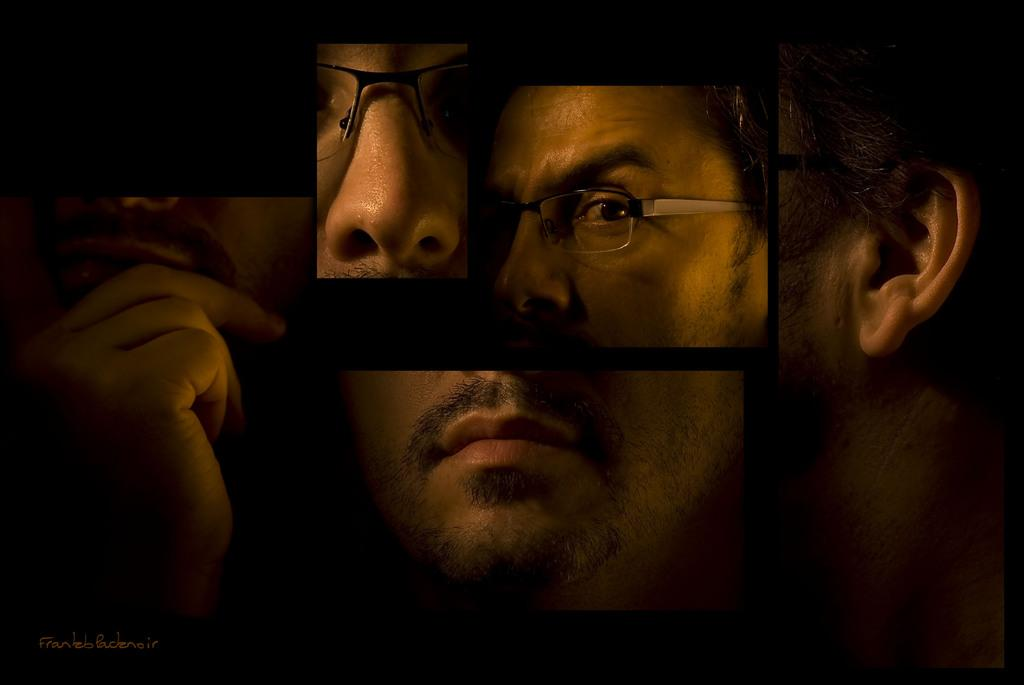What is the main subject of the image? The main subject of the image is a collage picture of a man. Can you describe the collage in more detail? Unfortunately, the provided facts do not give any additional details about the collage. What type of vegetable is being used as a veil in the image? There is no vegetable or veil present in the image, as it only contains a collage picture of a man. 